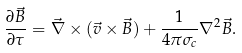<formula> <loc_0><loc_0><loc_500><loc_500>\frac { \partial \vec { B } } { \partial \tau } = \vec { \nabla } \times ( \vec { v } \times \vec { B } ) + \frac { 1 } { 4 \pi \sigma _ { c } } \nabla ^ { 2 } \vec { B } .</formula> 